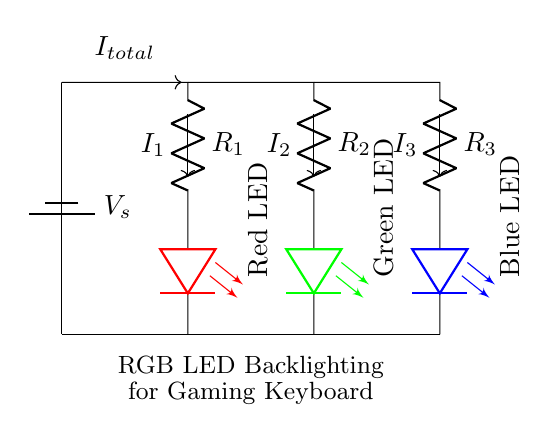What is the purpose of the resistors in this circuit? The resistors limit the current flowing through each LED, ensuring they operate safely and effectively. Each resistor is selected to provide the appropriate current for its corresponding LED based on its forward voltage and current ratings.
Answer: Current limiting What are the colors of the LEDs used in the circuit? The circuit uses three LEDs: a red LED, a green LED, and a blue LED. Each one is represented in the circuit with its respective color, confirming their type.
Answer: Red, green, blue What is the total current flowing into the circuit? The total current entering the circuit is denoted as I total, which represents the current supplied by the source. Since it's not specified in this diagram, we cannot determine an exact value just from the visual.
Answer: I total How does current distribute among the LEDs? The current splits into three paths through the resistors and LEDs. The precise distribution depends on the resistance values of the resistors and the forward voltage of the LEDs, following the current divider rule.
Answer: It splits What is the function of the battery in the circuit? The battery acts as the power source providing the potential difference necessary for current flow through the circuit, illuminating the LEDs as a result.
Answer: Power source How does changing the resistor value affect the current through the LEDs? If a resistor's value is increased, the current through that leg of the circuit decreases; conversely, if a resistor is decreased, the current increases through that LED. The current division relies on the values of these resistors.
Answer: Current change 